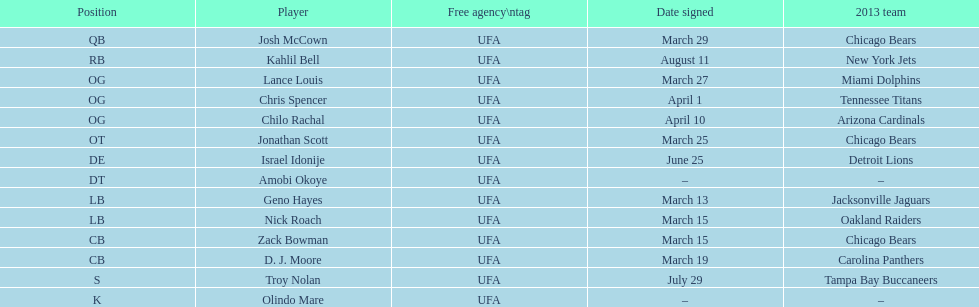Who was the previous player signed before troy nolan? Israel Idonije. 